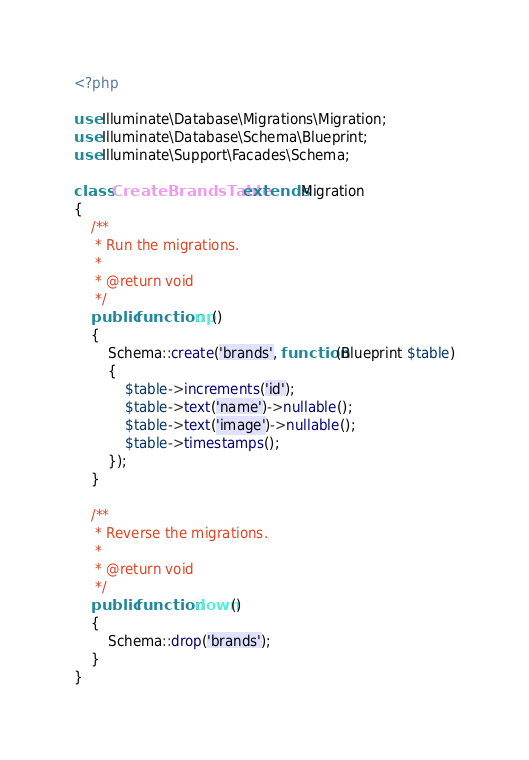Convert code to text. <code><loc_0><loc_0><loc_500><loc_500><_PHP_><?php

use Illuminate\Database\Migrations\Migration;
use Illuminate\Database\Schema\Blueprint;
use Illuminate\Support\Facades\Schema;

class CreateBrandsTable extends Migration
{
	/**
	 * Run the migrations.
	 *
	 * @return void
	 */
	public function up()
	{
		Schema::create('brands', function(Blueprint $table)
		{
			$table->increments('id');
			$table->text('name')->nullable();
			$table->text('image')->nullable();
			$table->timestamps();
		});
	}

	/**
	 * Reverse the migrations.
	 *
	 * @return void
	 */
	public function down()
	{
		Schema::drop('brands');
	}
}
</code> 